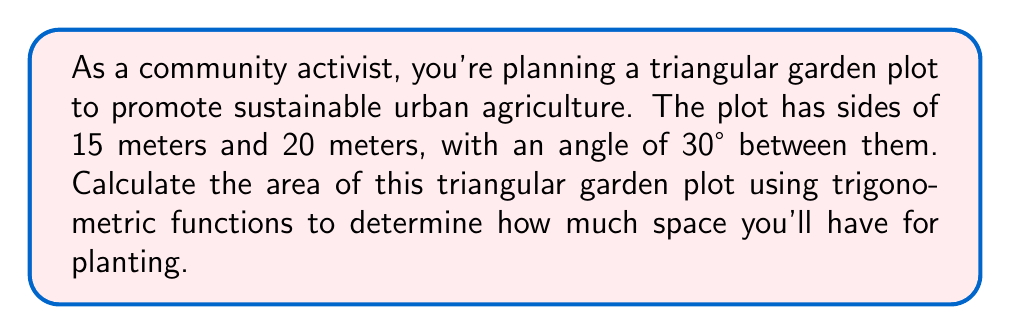Show me your answer to this math problem. Let's approach this step-by-step:

1) We can use the formula for the area of a triangle given two sides and the included angle:

   $$A = \frac{1}{2}ab\sin(C)$$

   where $A$ is the area, $a$ and $b$ are the lengths of two sides, and $C$ is the angle between them.

2) We have:
   $a = 15$ meters
   $b = 20$ meters
   $C = 30°$

3) Substituting these values into the formula:

   $$A = \frac{1}{2} \cdot 15 \cdot 20 \cdot \sin(30°)$$

4) Simplify:
   $$A = 150 \cdot \sin(30°)$$

5) We know that $\sin(30°) = \frac{1}{2}$, so:

   $$A = 150 \cdot \frac{1}{2} = 75$$

6) Therefore, the area of the triangular garden plot is 75 square meters.

[asy]
unitsize(10);
pair A=(0,0), B=(3,0), C=(1.5,2.598);
draw(A--B--C--A);
label("15m",A--C,W);
label("20m",B--C,E);
label("30°",A,NE);
[/asy]
Answer: 75 m² 